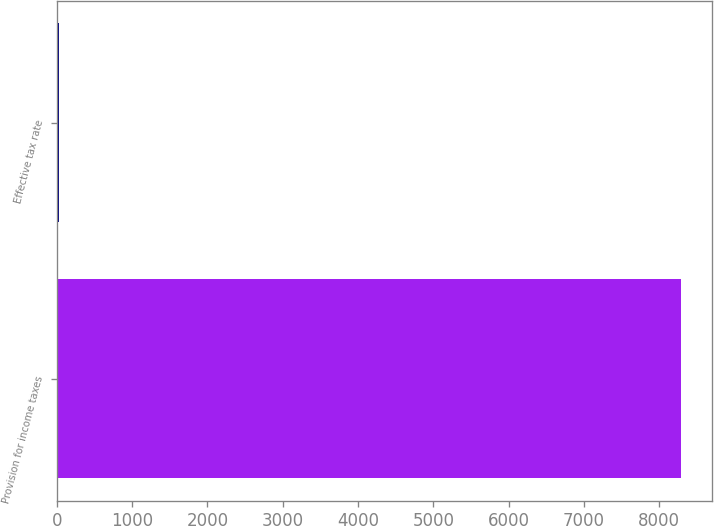Convert chart to OTSL. <chart><loc_0><loc_0><loc_500><loc_500><bar_chart><fcel>Provision for income taxes<fcel>Effective tax rate<nl><fcel>8283<fcel>24.2<nl></chart> 